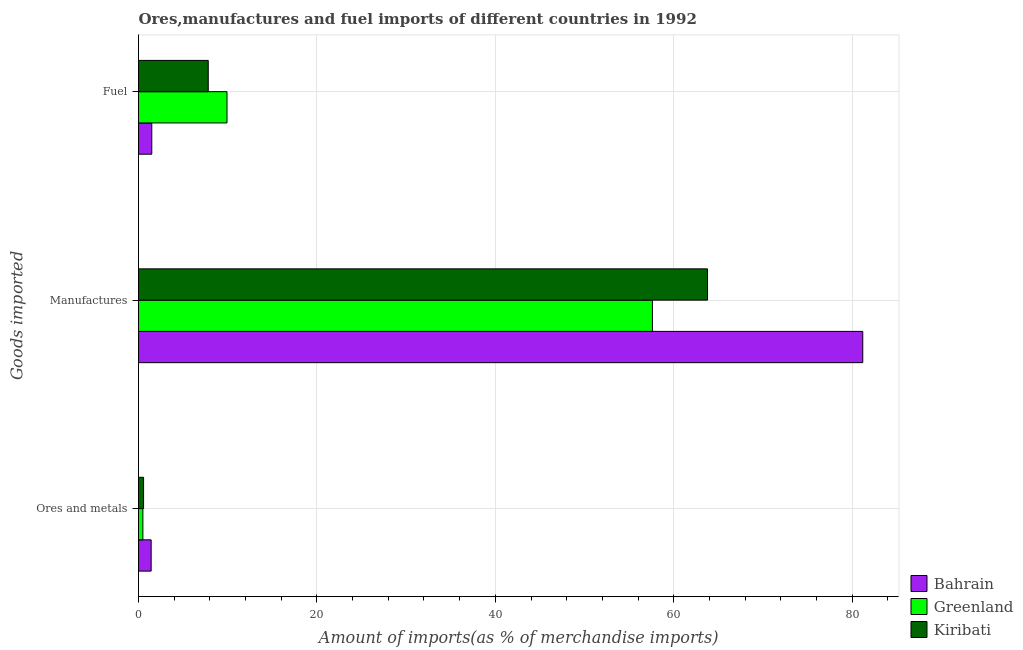How many different coloured bars are there?
Ensure brevity in your answer.  3. Are the number of bars per tick equal to the number of legend labels?
Offer a very short reply. Yes. How many bars are there on the 1st tick from the bottom?
Your answer should be compact. 3. What is the label of the 3rd group of bars from the top?
Make the answer very short. Ores and metals. What is the percentage of fuel imports in Kiribati?
Offer a terse response. 7.82. Across all countries, what is the maximum percentage of manufactures imports?
Make the answer very short. 81.19. Across all countries, what is the minimum percentage of fuel imports?
Your answer should be compact. 1.49. In which country was the percentage of manufactures imports maximum?
Your answer should be compact. Bahrain. In which country was the percentage of fuel imports minimum?
Keep it short and to the point. Bahrain. What is the total percentage of fuel imports in the graph?
Your answer should be compact. 19.22. What is the difference between the percentage of manufactures imports in Bahrain and that in Kiribati?
Give a very brief answer. 17.4. What is the difference between the percentage of ores and metals imports in Kiribati and the percentage of fuel imports in Greenland?
Give a very brief answer. -9.35. What is the average percentage of manufactures imports per country?
Keep it short and to the point. 67.53. What is the difference between the percentage of manufactures imports and percentage of ores and metals imports in Greenland?
Offer a terse response. 57.12. What is the ratio of the percentage of ores and metals imports in Greenland to that in Kiribati?
Give a very brief answer. 0.86. Is the percentage of manufactures imports in Greenland less than that in Kiribati?
Offer a very short reply. Yes. Is the difference between the percentage of manufactures imports in Kiribati and Bahrain greater than the difference between the percentage of fuel imports in Kiribati and Bahrain?
Keep it short and to the point. No. What is the difference between the highest and the second highest percentage of fuel imports?
Provide a short and direct response. 2.1. What is the difference between the highest and the lowest percentage of fuel imports?
Offer a terse response. 8.43. What does the 2nd bar from the top in Fuel represents?
Your answer should be compact. Greenland. What does the 1st bar from the bottom in Manufactures represents?
Offer a terse response. Bahrain. How many countries are there in the graph?
Offer a terse response. 3. What is the difference between two consecutive major ticks on the X-axis?
Provide a short and direct response. 20. Does the graph contain grids?
Provide a succinct answer. Yes. How many legend labels are there?
Ensure brevity in your answer.  3. How are the legend labels stacked?
Offer a very short reply. Vertical. What is the title of the graph?
Your answer should be very brief. Ores,manufactures and fuel imports of different countries in 1992. What is the label or title of the X-axis?
Your answer should be very brief. Amount of imports(as % of merchandise imports). What is the label or title of the Y-axis?
Your answer should be very brief. Goods imported. What is the Amount of imports(as % of merchandise imports) in Bahrain in Ores and metals?
Offer a very short reply. 1.42. What is the Amount of imports(as % of merchandise imports) of Greenland in Ores and metals?
Keep it short and to the point. 0.49. What is the Amount of imports(as % of merchandise imports) in Kiribati in Ores and metals?
Your answer should be compact. 0.57. What is the Amount of imports(as % of merchandise imports) of Bahrain in Manufactures?
Offer a very short reply. 81.19. What is the Amount of imports(as % of merchandise imports) in Greenland in Manufactures?
Ensure brevity in your answer.  57.61. What is the Amount of imports(as % of merchandise imports) in Kiribati in Manufactures?
Provide a short and direct response. 63.78. What is the Amount of imports(as % of merchandise imports) in Bahrain in Fuel?
Make the answer very short. 1.49. What is the Amount of imports(as % of merchandise imports) in Greenland in Fuel?
Provide a succinct answer. 9.92. What is the Amount of imports(as % of merchandise imports) in Kiribati in Fuel?
Provide a succinct answer. 7.82. Across all Goods imported, what is the maximum Amount of imports(as % of merchandise imports) of Bahrain?
Make the answer very short. 81.19. Across all Goods imported, what is the maximum Amount of imports(as % of merchandise imports) of Greenland?
Ensure brevity in your answer.  57.61. Across all Goods imported, what is the maximum Amount of imports(as % of merchandise imports) of Kiribati?
Keep it short and to the point. 63.78. Across all Goods imported, what is the minimum Amount of imports(as % of merchandise imports) in Bahrain?
Keep it short and to the point. 1.42. Across all Goods imported, what is the minimum Amount of imports(as % of merchandise imports) of Greenland?
Give a very brief answer. 0.49. Across all Goods imported, what is the minimum Amount of imports(as % of merchandise imports) of Kiribati?
Provide a short and direct response. 0.57. What is the total Amount of imports(as % of merchandise imports) in Bahrain in the graph?
Your answer should be compact. 84.09. What is the total Amount of imports(as % of merchandise imports) in Greenland in the graph?
Your answer should be very brief. 68.02. What is the total Amount of imports(as % of merchandise imports) of Kiribati in the graph?
Keep it short and to the point. 72.17. What is the difference between the Amount of imports(as % of merchandise imports) in Bahrain in Ores and metals and that in Manufactures?
Provide a succinct answer. -79.77. What is the difference between the Amount of imports(as % of merchandise imports) of Greenland in Ores and metals and that in Manufactures?
Your answer should be compact. -57.12. What is the difference between the Amount of imports(as % of merchandise imports) of Kiribati in Ores and metals and that in Manufactures?
Give a very brief answer. -63.22. What is the difference between the Amount of imports(as % of merchandise imports) of Bahrain in Ores and metals and that in Fuel?
Your answer should be very brief. -0.07. What is the difference between the Amount of imports(as % of merchandise imports) in Greenland in Ores and metals and that in Fuel?
Give a very brief answer. -9.43. What is the difference between the Amount of imports(as % of merchandise imports) of Kiribati in Ores and metals and that in Fuel?
Ensure brevity in your answer.  -7.25. What is the difference between the Amount of imports(as % of merchandise imports) of Bahrain in Manufactures and that in Fuel?
Your answer should be compact. 79.7. What is the difference between the Amount of imports(as % of merchandise imports) in Greenland in Manufactures and that in Fuel?
Your answer should be compact. 47.69. What is the difference between the Amount of imports(as % of merchandise imports) in Kiribati in Manufactures and that in Fuel?
Keep it short and to the point. 55.97. What is the difference between the Amount of imports(as % of merchandise imports) of Bahrain in Ores and metals and the Amount of imports(as % of merchandise imports) of Greenland in Manufactures?
Give a very brief answer. -56.19. What is the difference between the Amount of imports(as % of merchandise imports) in Bahrain in Ores and metals and the Amount of imports(as % of merchandise imports) in Kiribati in Manufactures?
Provide a succinct answer. -62.37. What is the difference between the Amount of imports(as % of merchandise imports) in Greenland in Ores and metals and the Amount of imports(as % of merchandise imports) in Kiribati in Manufactures?
Your answer should be compact. -63.29. What is the difference between the Amount of imports(as % of merchandise imports) in Bahrain in Ores and metals and the Amount of imports(as % of merchandise imports) in Greenland in Fuel?
Keep it short and to the point. -8.5. What is the difference between the Amount of imports(as % of merchandise imports) of Bahrain in Ores and metals and the Amount of imports(as % of merchandise imports) of Kiribati in Fuel?
Give a very brief answer. -6.4. What is the difference between the Amount of imports(as % of merchandise imports) in Greenland in Ores and metals and the Amount of imports(as % of merchandise imports) in Kiribati in Fuel?
Offer a terse response. -7.33. What is the difference between the Amount of imports(as % of merchandise imports) in Bahrain in Manufactures and the Amount of imports(as % of merchandise imports) in Greenland in Fuel?
Offer a terse response. 71.27. What is the difference between the Amount of imports(as % of merchandise imports) in Bahrain in Manufactures and the Amount of imports(as % of merchandise imports) in Kiribati in Fuel?
Your response must be concise. 73.37. What is the difference between the Amount of imports(as % of merchandise imports) in Greenland in Manufactures and the Amount of imports(as % of merchandise imports) in Kiribati in Fuel?
Give a very brief answer. 49.79. What is the average Amount of imports(as % of merchandise imports) of Bahrain per Goods imported?
Your answer should be compact. 28.03. What is the average Amount of imports(as % of merchandise imports) in Greenland per Goods imported?
Give a very brief answer. 22.67. What is the average Amount of imports(as % of merchandise imports) of Kiribati per Goods imported?
Provide a succinct answer. 24.06. What is the difference between the Amount of imports(as % of merchandise imports) in Bahrain and Amount of imports(as % of merchandise imports) in Greenland in Ores and metals?
Make the answer very short. 0.93. What is the difference between the Amount of imports(as % of merchandise imports) of Bahrain and Amount of imports(as % of merchandise imports) of Kiribati in Ores and metals?
Offer a terse response. 0.85. What is the difference between the Amount of imports(as % of merchandise imports) of Greenland and Amount of imports(as % of merchandise imports) of Kiribati in Ores and metals?
Ensure brevity in your answer.  -0.08. What is the difference between the Amount of imports(as % of merchandise imports) of Bahrain and Amount of imports(as % of merchandise imports) of Greenland in Manufactures?
Ensure brevity in your answer.  23.58. What is the difference between the Amount of imports(as % of merchandise imports) of Bahrain and Amount of imports(as % of merchandise imports) of Kiribati in Manufactures?
Make the answer very short. 17.4. What is the difference between the Amount of imports(as % of merchandise imports) in Greenland and Amount of imports(as % of merchandise imports) in Kiribati in Manufactures?
Keep it short and to the point. -6.18. What is the difference between the Amount of imports(as % of merchandise imports) of Bahrain and Amount of imports(as % of merchandise imports) of Greenland in Fuel?
Offer a very short reply. -8.43. What is the difference between the Amount of imports(as % of merchandise imports) of Bahrain and Amount of imports(as % of merchandise imports) of Kiribati in Fuel?
Give a very brief answer. -6.33. What is the difference between the Amount of imports(as % of merchandise imports) of Greenland and Amount of imports(as % of merchandise imports) of Kiribati in Fuel?
Offer a terse response. 2.1. What is the ratio of the Amount of imports(as % of merchandise imports) of Bahrain in Ores and metals to that in Manufactures?
Provide a short and direct response. 0.02. What is the ratio of the Amount of imports(as % of merchandise imports) of Greenland in Ores and metals to that in Manufactures?
Your answer should be compact. 0.01. What is the ratio of the Amount of imports(as % of merchandise imports) in Kiribati in Ores and metals to that in Manufactures?
Provide a succinct answer. 0.01. What is the ratio of the Amount of imports(as % of merchandise imports) of Bahrain in Ores and metals to that in Fuel?
Your answer should be compact. 0.95. What is the ratio of the Amount of imports(as % of merchandise imports) in Greenland in Ores and metals to that in Fuel?
Provide a succinct answer. 0.05. What is the ratio of the Amount of imports(as % of merchandise imports) in Kiribati in Ores and metals to that in Fuel?
Offer a very short reply. 0.07. What is the ratio of the Amount of imports(as % of merchandise imports) in Bahrain in Manufactures to that in Fuel?
Make the answer very short. 54.59. What is the ratio of the Amount of imports(as % of merchandise imports) of Greenland in Manufactures to that in Fuel?
Make the answer very short. 5.81. What is the ratio of the Amount of imports(as % of merchandise imports) of Kiribati in Manufactures to that in Fuel?
Provide a short and direct response. 8.16. What is the difference between the highest and the second highest Amount of imports(as % of merchandise imports) in Bahrain?
Your answer should be very brief. 79.7. What is the difference between the highest and the second highest Amount of imports(as % of merchandise imports) of Greenland?
Your answer should be very brief. 47.69. What is the difference between the highest and the second highest Amount of imports(as % of merchandise imports) of Kiribati?
Your answer should be compact. 55.97. What is the difference between the highest and the lowest Amount of imports(as % of merchandise imports) in Bahrain?
Keep it short and to the point. 79.77. What is the difference between the highest and the lowest Amount of imports(as % of merchandise imports) in Greenland?
Ensure brevity in your answer.  57.12. What is the difference between the highest and the lowest Amount of imports(as % of merchandise imports) of Kiribati?
Provide a short and direct response. 63.22. 